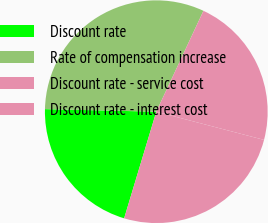<chart> <loc_0><loc_0><loc_500><loc_500><pie_chart><fcel>Discount rate<fcel>Rate of compensation increase<fcel>Discount rate - service cost<fcel>Discount rate - interest cost<nl><fcel>20.71%<fcel>31.59%<fcel>22.11%<fcel>25.59%<nl></chart> 